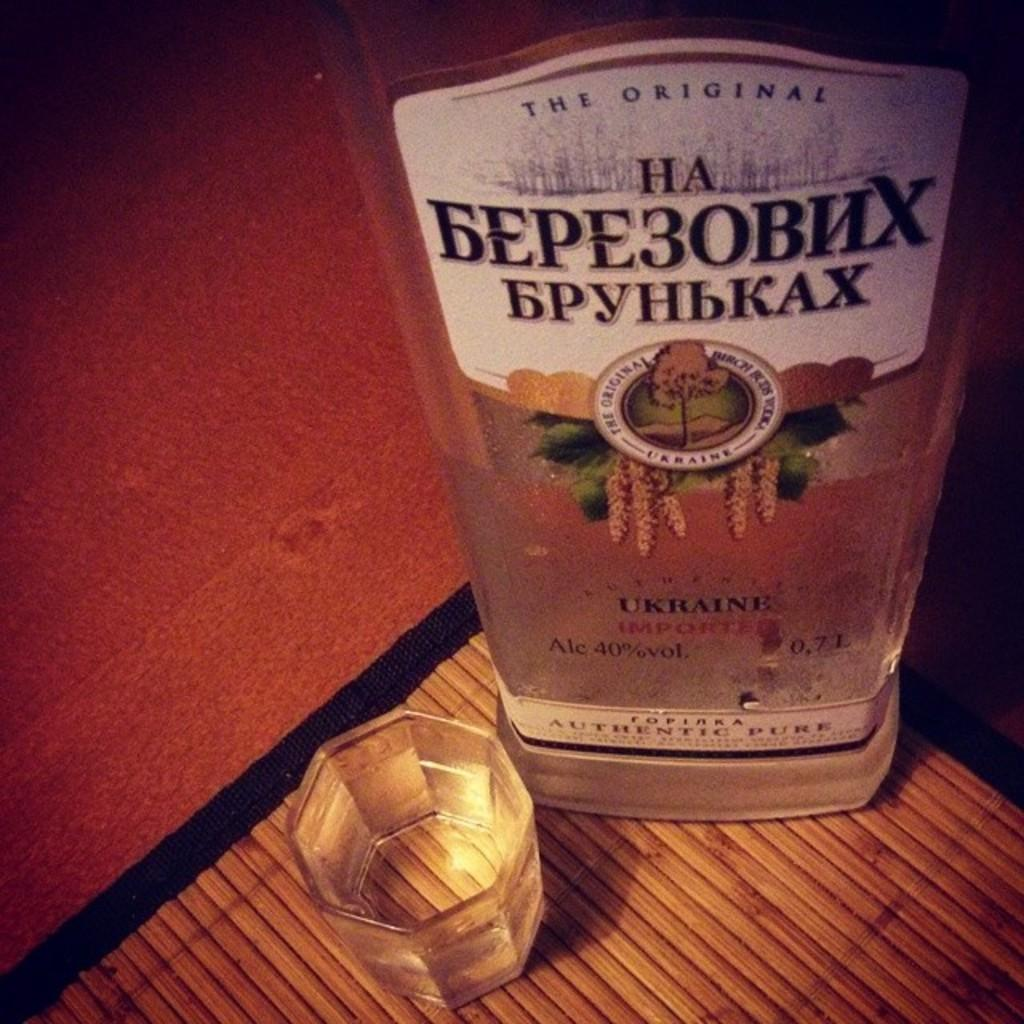<image>
Relay a brief, clear account of the picture shown. A bottle of alcohol with Russian lettering on it next to a glass. 